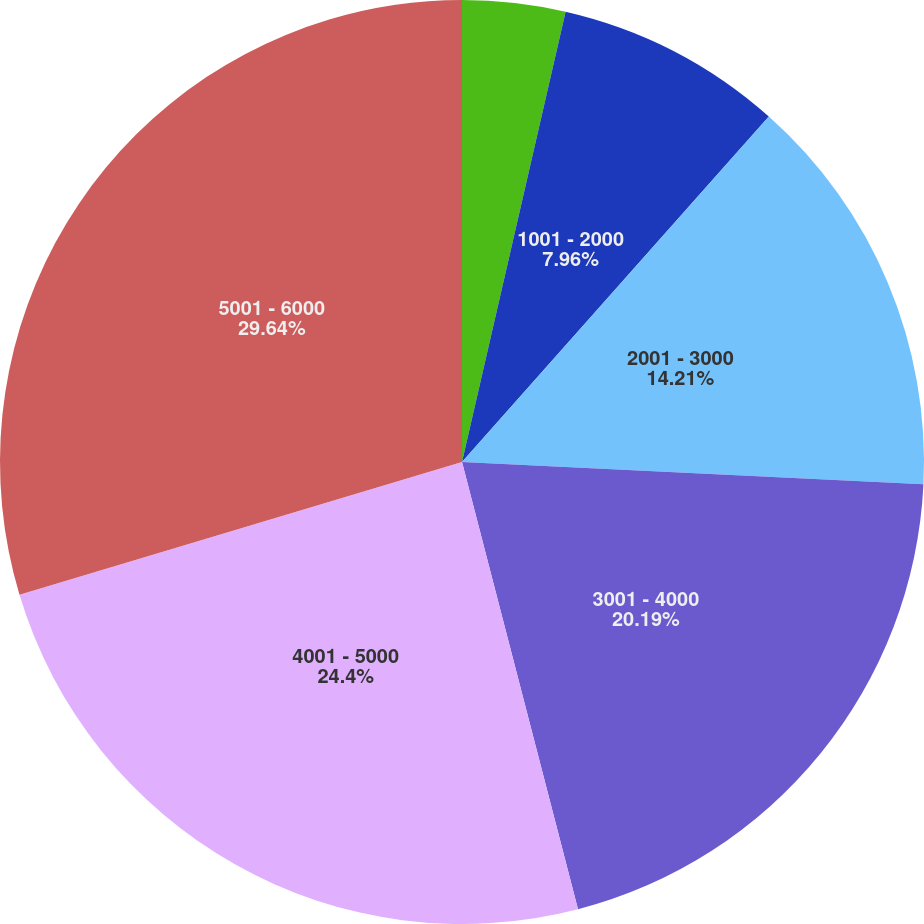<chart> <loc_0><loc_0><loc_500><loc_500><pie_chart><fcel>501 - 1000<fcel>1001 - 2000<fcel>2001 - 3000<fcel>3001 - 4000<fcel>4001 - 5000<fcel>5001 - 6000<nl><fcel>3.6%<fcel>7.96%<fcel>14.21%<fcel>20.19%<fcel>24.4%<fcel>29.64%<nl></chart> 